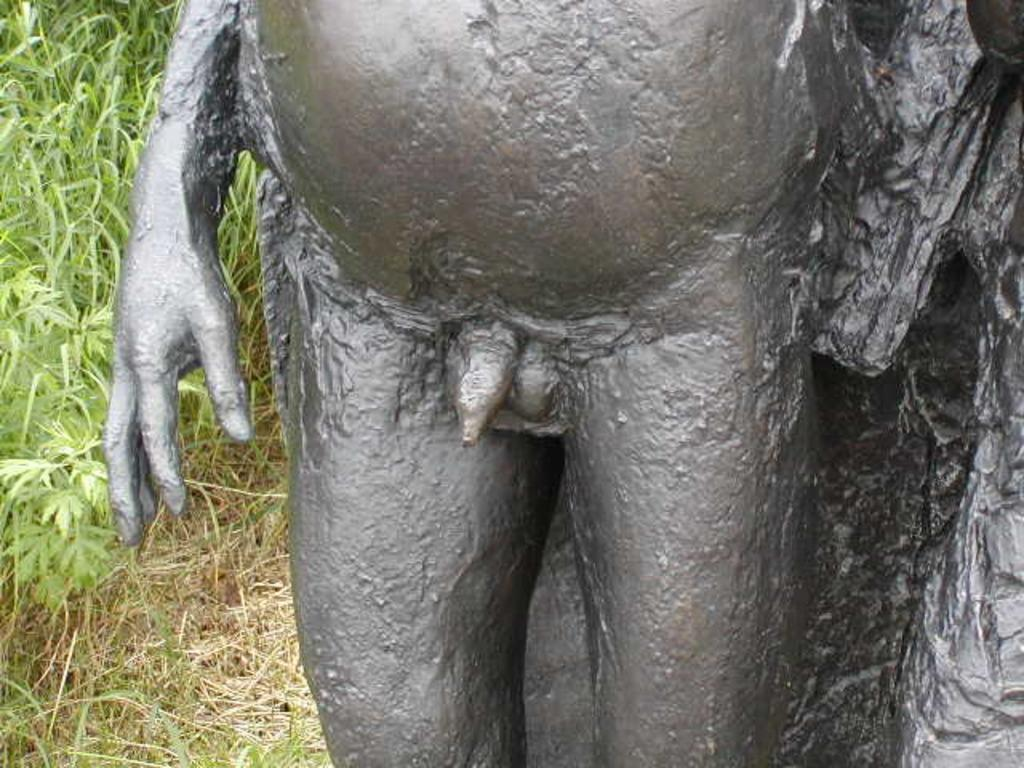What is the main subject in the image? There is a statue in the image. What type of environment is depicted in the background of the image? There is grass visible in the background of the image. What type of hole can be seen in the statue's attention in the image? There is no hole or any reference to attention in the image; it features a statue and grass in the background. 